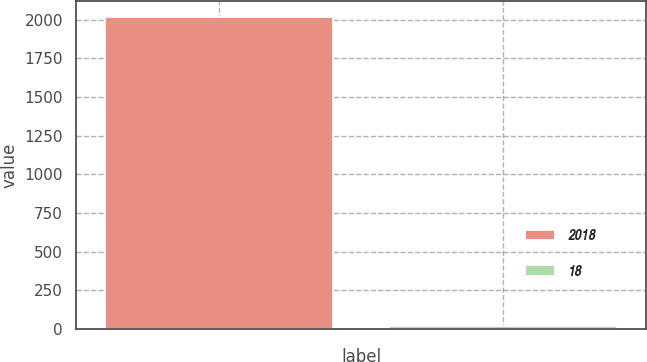Convert chart to OTSL. <chart><loc_0><loc_0><loc_500><loc_500><bar_chart><fcel>2018<fcel>18<nl><fcel>2019<fcel>17<nl></chart> 